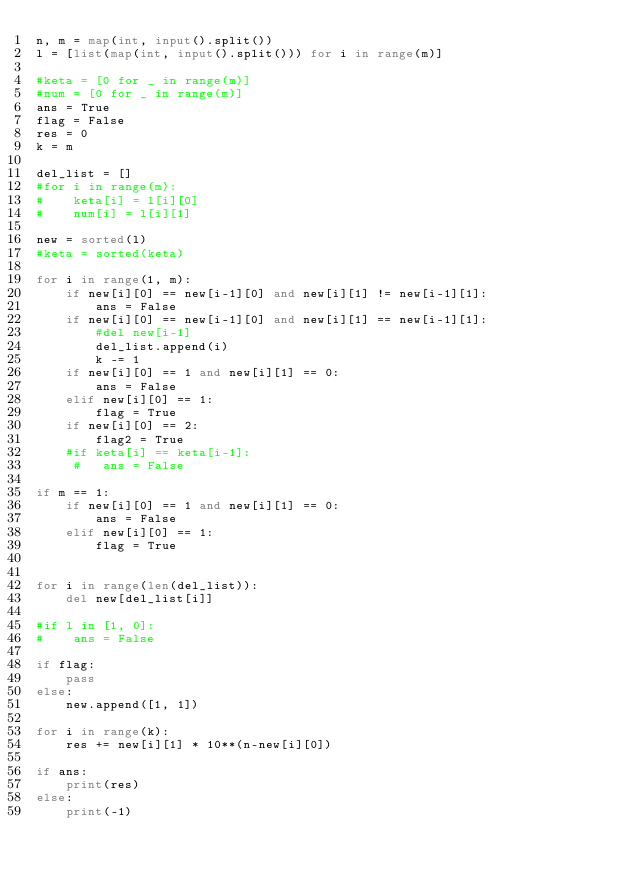Convert code to text. <code><loc_0><loc_0><loc_500><loc_500><_Python_>n, m = map(int, input().split())
l = [list(map(int, input().split())) for i in range(m)]

#keta = [0 for _ in range(m)]
#num = [0 for _ in range(m)]
ans = True
flag = False
res = 0
k = m

del_list = []
#for i in range(m):
#    keta[i] = l[i][0]
#    num[i] = l[i][1]

new = sorted(l)
#keta = sorted(keta)

for i in range(1, m):
    if new[i][0] == new[i-1][0] and new[i][1] != new[i-1][1]:
        ans = False
    if new[i][0] == new[i-1][0] and new[i][1] == new[i-1][1]:
        #del new[i-1]
        del_list.append(i)
        k -= 1
    if new[i][0] == 1 and new[i][1] == 0:
        ans = False
    elif new[i][0] == 1:
        flag = True
    if new[i][0] == 2:
        flag2 = True
    #if keta[i] == keta[i-1]:
     #   ans = False

if m == 1:
    if new[i][0] == 1 and new[i][1] == 0:
        ans = False
    elif new[i][0] == 1:
        flag = True
    

for i in range(len(del_list)):
    del new[del_list[i]]

#if l in [1, 0]:
#    ans = False
    
if flag:
    pass
else:
    new.append([1, 1])
    
for i in range(k):
    res += new[i][1] * 10**(n-new[i][0])
    
if ans:
    print(res)
else:
    print(-1)</code> 